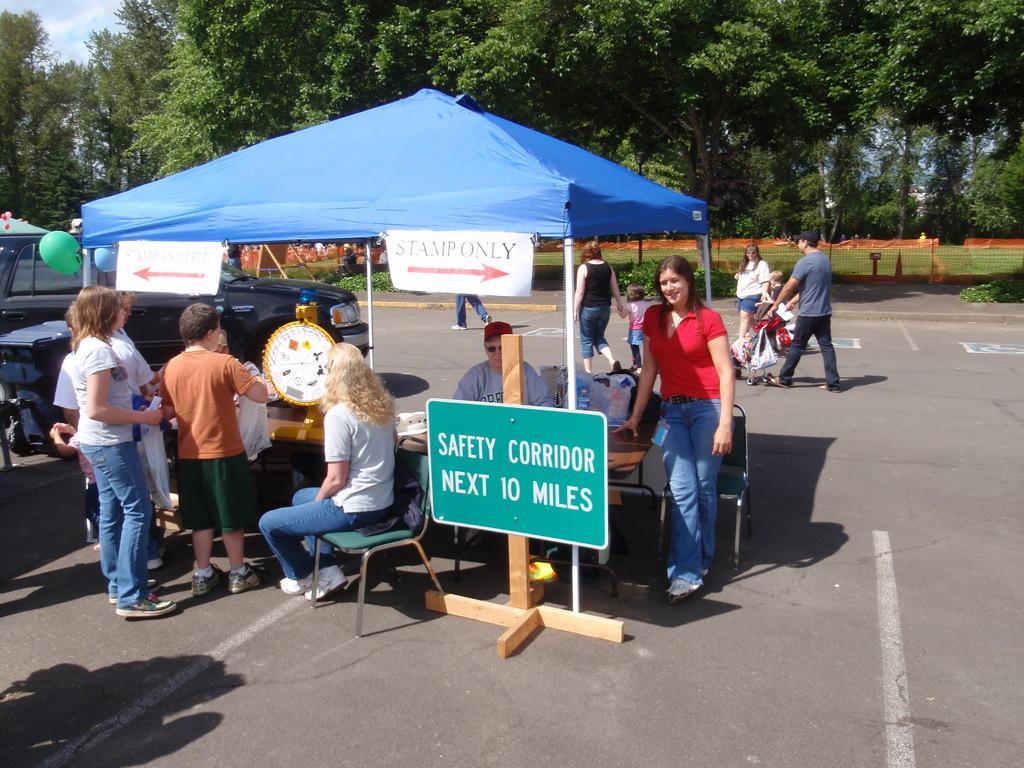Describe this image in one or two sentences. There are many persons standing and sitting. There is a tent. And there is a sign board. There is a table and chair. A lady is sitting on chair. There are some vehicles. On the text there are some balloons. In the background there are trees. 